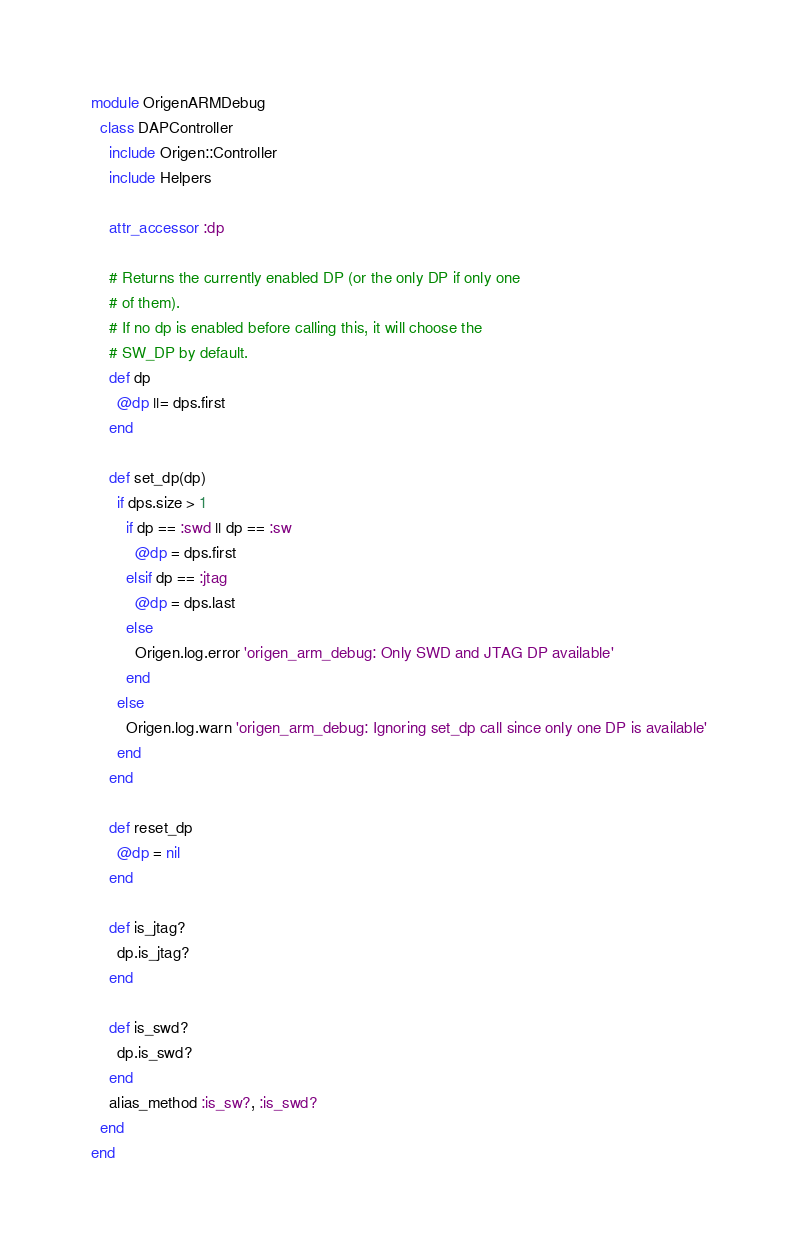Convert code to text. <code><loc_0><loc_0><loc_500><loc_500><_Ruby_>module OrigenARMDebug
  class DAPController
    include Origen::Controller
    include Helpers

    attr_accessor :dp

    # Returns the currently enabled DP (or the only DP if only one
    # of them).
    # If no dp is enabled before calling this, it will choose the
    # SW_DP by default.
    def dp
      @dp ||= dps.first
    end

    def set_dp(dp)
      if dps.size > 1
        if dp == :swd || dp == :sw
          @dp = dps.first
        elsif dp == :jtag
          @dp = dps.last
        else
          Origen.log.error 'origen_arm_debug: Only SWD and JTAG DP available'
        end
      else
        Origen.log.warn 'origen_arm_debug: Ignoring set_dp call since only one DP is available'
      end
    end

    def reset_dp
      @dp = nil
    end

    def is_jtag?
      dp.is_jtag?
    end

    def is_swd?
      dp.is_swd?
    end
    alias_method :is_sw?, :is_swd?
  end
end
</code> 